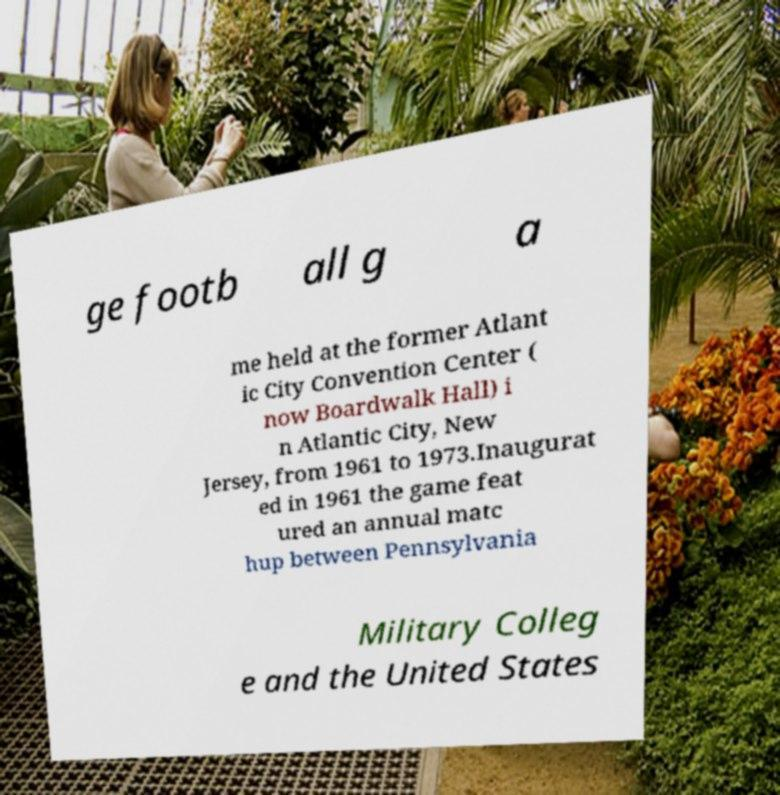Please identify and transcribe the text found in this image. ge footb all g a me held at the former Atlant ic City Convention Center ( now Boardwalk Hall) i n Atlantic City, New Jersey, from 1961 to 1973.Inaugurat ed in 1961 the game feat ured an annual matc hup between Pennsylvania Military Colleg e and the United States 